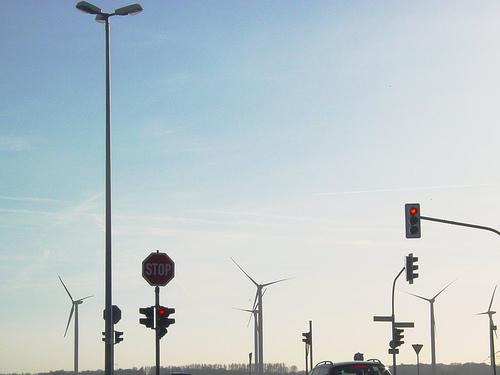The car is operating during which season?

Choices:
A) summer
B) spring
C) winter
D) fall winter 